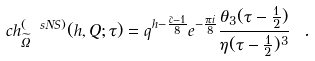Convert formula to latex. <formula><loc_0><loc_0><loc_500><loc_500>c h _ { \widetilde { \Omega } } ^ { ( \ s N S ) } ( h , Q ; \tau ) = q ^ { h - \frac { \hat { c } - 1 } { 8 } } e ^ { - \frac { \pi i } { 8 } } \frac { \theta _ { 3 } ( \tau - \frac { 1 } { 2 } ) } { \eta ( \tau - \frac { 1 } { 2 } ) ^ { 3 } } \ .</formula> 